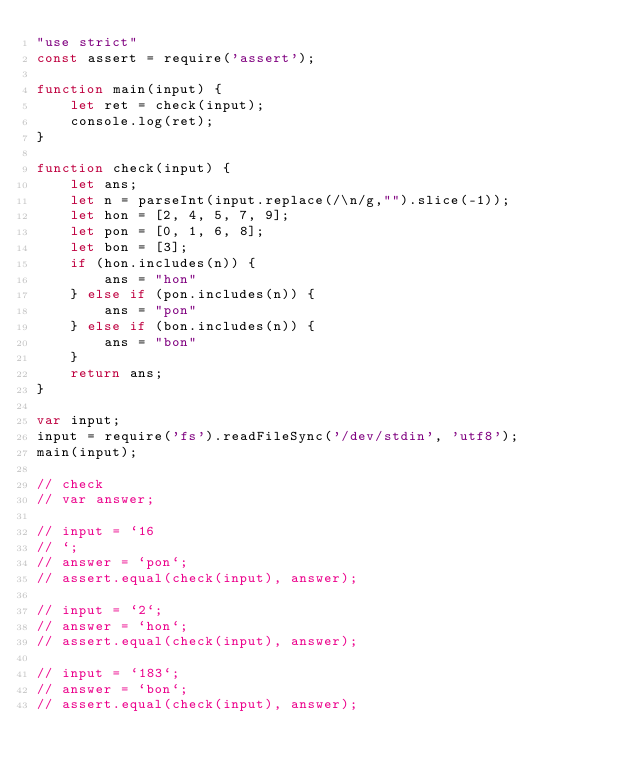<code> <loc_0><loc_0><loc_500><loc_500><_JavaScript_>"use strict"
const assert = require('assert');

function main(input) {
    let ret = check(input);
    console.log(ret);
}

function check(input) {
    let ans;
    let n = parseInt(input.replace(/\n/g,"").slice(-1));
    let hon = [2, 4, 5, 7, 9];
    let pon = [0, 1, 6, 8];
    let bon = [3];
    if (hon.includes(n)) {
        ans = "hon"
    } else if (pon.includes(n)) {
        ans = "pon"
    } else if (bon.includes(n)) {
        ans = "bon"
    }
    return ans;
}

var input;
input = require('fs').readFileSync('/dev/stdin', 'utf8');
main(input);

// check
// var answer;

// input = `16
// `;
// answer = `pon`;
// assert.equal(check(input), answer);

// input = `2`;
// answer = `hon`;
// assert.equal(check(input), answer);

// input = `183`;
// answer = `bon`;
// assert.equal(check(input), answer);</code> 